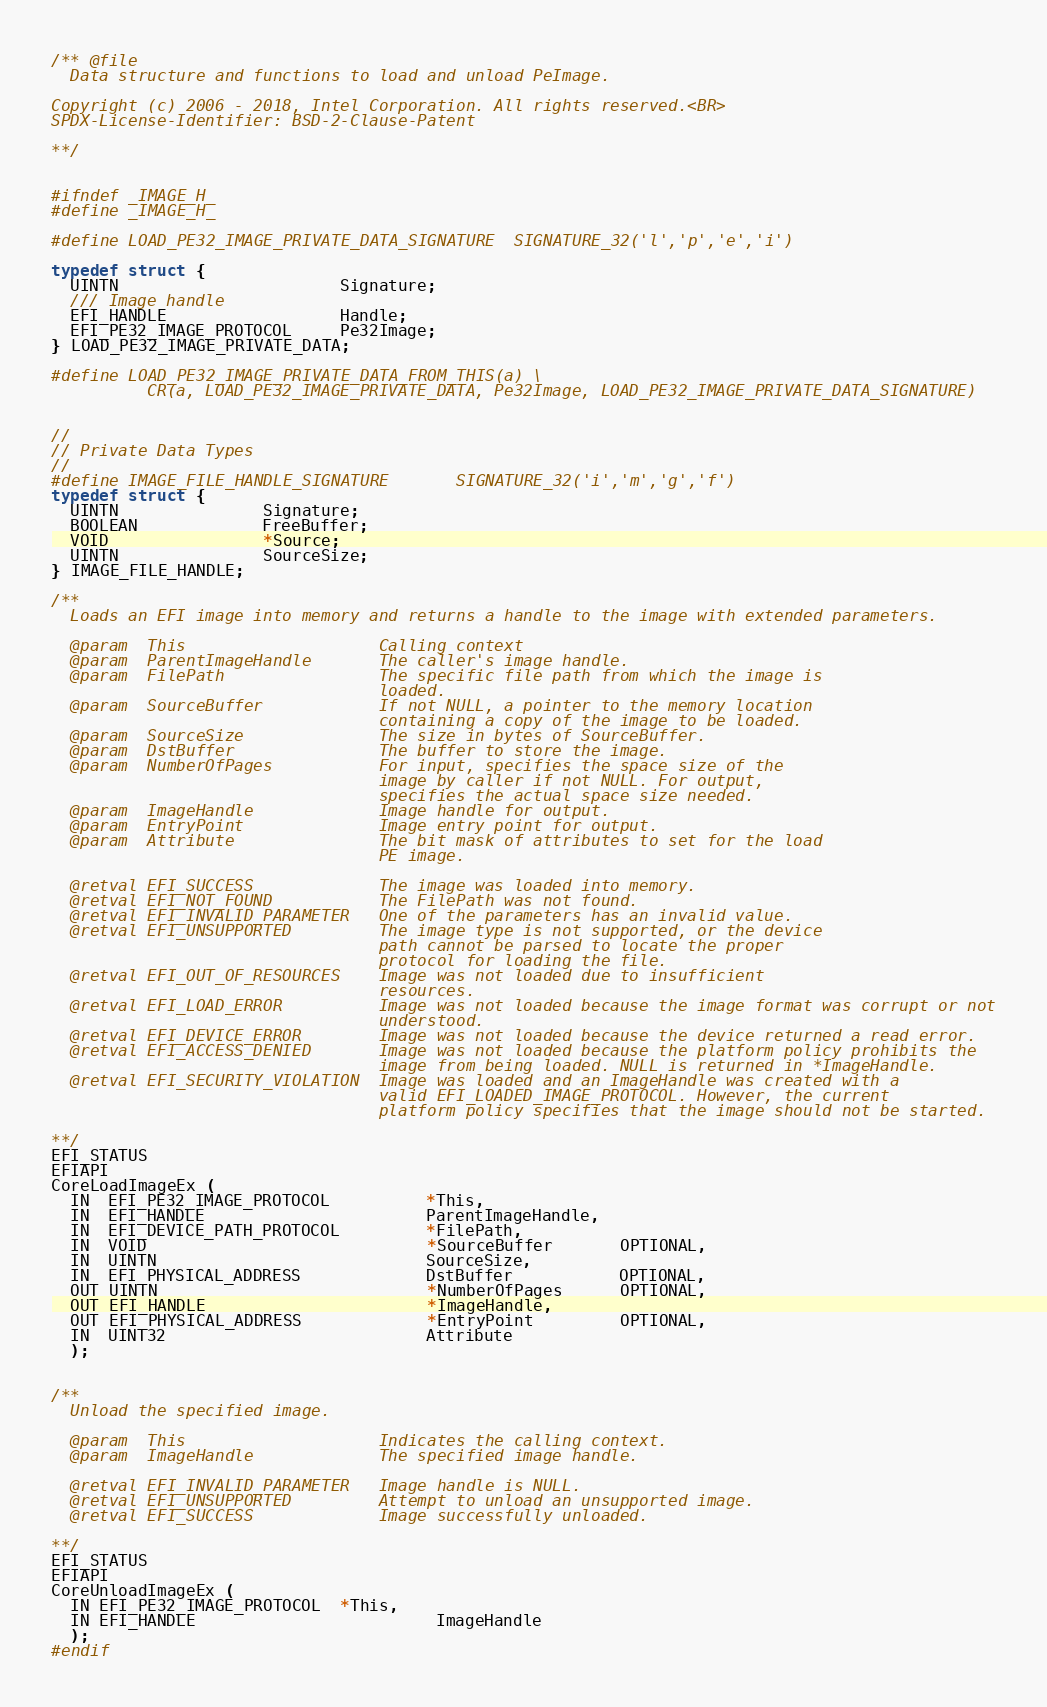<code> <loc_0><loc_0><loc_500><loc_500><_C_>/** @file
  Data structure and functions to load and unload PeImage.

Copyright (c) 2006 - 2018, Intel Corporation. All rights reserved.<BR>
SPDX-License-Identifier: BSD-2-Clause-Patent

**/


#ifndef _IMAGE_H_
#define _IMAGE_H_

#define LOAD_PE32_IMAGE_PRIVATE_DATA_SIGNATURE  SIGNATURE_32('l','p','e','i')

typedef struct {
  UINTN                       Signature;
  /// Image handle
  EFI_HANDLE                  Handle;
  EFI_PE32_IMAGE_PROTOCOL     Pe32Image;
} LOAD_PE32_IMAGE_PRIVATE_DATA;

#define LOAD_PE32_IMAGE_PRIVATE_DATA_FROM_THIS(a) \
          CR(a, LOAD_PE32_IMAGE_PRIVATE_DATA, Pe32Image, LOAD_PE32_IMAGE_PRIVATE_DATA_SIGNATURE)


//
// Private Data Types
//
#define IMAGE_FILE_HANDLE_SIGNATURE       SIGNATURE_32('i','m','g','f')
typedef struct {
  UINTN               Signature;
  BOOLEAN             FreeBuffer;
  VOID                *Source;
  UINTN               SourceSize;
} IMAGE_FILE_HANDLE;

/**
  Loads an EFI image into memory and returns a handle to the image with extended parameters.

  @param  This                    Calling context
  @param  ParentImageHandle       The caller's image handle.
  @param  FilePath                The specific file path from which the image is
                                  loaded.
  @param  SourceBuffer            If not NULL, a pointer to the memory location
                                  containing a copy of the image to be loaded.
  @param  SourceSize              The size in bytes of SourceBuffer.
  @param  DstBuffer               The buffer to store the image.
  @param  NumberOfPages           For input, specifies the space size of the
                                  image by caller if not NULL. For output,
                                  specifies the actual space size needed.
  @param  ImageHandle             Image handle for output.
  @param  EntryPoint              Image entry point for output.
  @param  Attribute               The bit mask of attributes to set for the load
                                  PE image.

  @retval EFI_SUCCESS             The image was loaded into memory.
  @retval EFI_NOT_FOUND           The FilePath was not found.
  @retval EFI_INVALID_PARAMETER   One of the parameters has an invalid value.
  @retval EFI_UNSUPPORTED         The image type is not supported, or the device
                                  path cannot be parsed to locate the proper
                                  protocol for loading the file.
  @retval EFI_OUT_OF_RESOURCES    Image was not loaded due to insufficient
                                  resources.
  @retval EFI_LOAD_ERROR          Image was not loaded because the image format was corrupt or not
                                  understood.
  @retval EFI_DEVICE_ERROR        Image was not loaded because the device returned a read error.
  @retval EFI_ACCESS_DENIED       Image was not loaded because the platform policy prohibits the
                                  image from being loaded. NULL is returned in *ImageHandle.
  @retval EFI_SECURITY_VIOLATION  Image was loaded and an ImageHandle was created with a
                                  valid EFI_LOADED_IMAGE_PROTOCOL. However, the current
                                  platform policy specifies that the image should not be started.

**/
EFI_STATUS
EFIAPI
CoreLoadImageEx (
  IN  EFI_PE32_IMAGE_PROTOCOL          *This,
  IN  EFI_HANDLE                       ParentImageHandle,
  IN  EFI_DEVICE_PATH_PROTOCOL         *FilePath,
  IN  VOID                             *SourceBuffer       OPTIONAL,
  IN  UINTN                            SourceSize,
  IN  EFI_PHYSICAL_ADDRESS             DstBuffer           OPTIONAL,
  OUT UINTN                            *NumberOfPages      OPTIONAL,
  OUT EFI_HANDLE                       *ImageHandle,
  OUT EFI_PHYSICAL_ADDRESS             *EntryPoint         OPTIONAL,
  IN  UINT32                           Attribute
  );


/**
  Unload the specified image.

  @param  This                    Indicates the calling context.
  @param  ImageHandle             The specified image handle.

  @retval EFI_INVALID_PARAMETER   Image handle is NULL.
  @retval EFI_UNSUPPORTED         Attempt to unload an unsupported image.
  @retval EFI_SUCCESS             Image successfully unloaded.

**/
EFI_STATUS
EFIAPI
CoreUnloadImageEx (
  IN EFI_PE32_IMAGE_PROTOCOL  *This,
  IN EFI_HANDLE                         ImageHandle
  );
#endif
</code> 